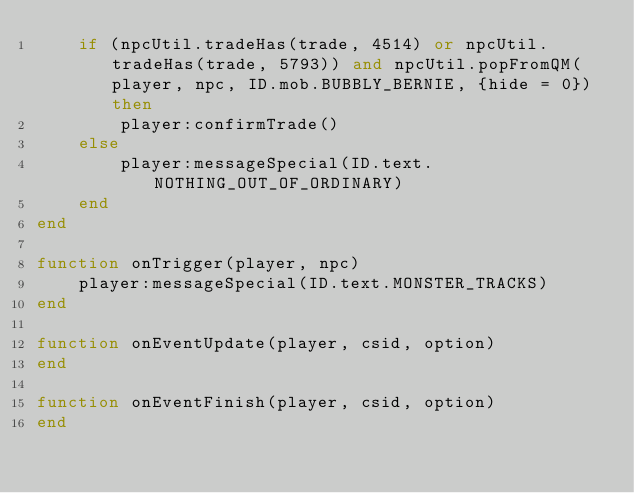Convert code to text. <code><loc_0><loc_0><loc_500><loc_500><_Lua_>    if (npcUtil.tradeHas(trade, 4514) or npcUtil.tradeHas(trade, 5793)) and npcUtil.popFromQM(player, npc, ID.mob.BUBBLY_BERNIE, {hide = 0}) then
        player:confirmTrade()
    else
        player:messageSpecial(ID.text.NOTHING_OUT_OF_ORDINARY)
    end
end

function onTrigger(player, npc)
    player:messageSpecial(ID.text.MONSTER_TRACKS)
end

function onEventUpdate(player, csid, option)
end

function onEventFinish(player, csid, option)
end
</code> 